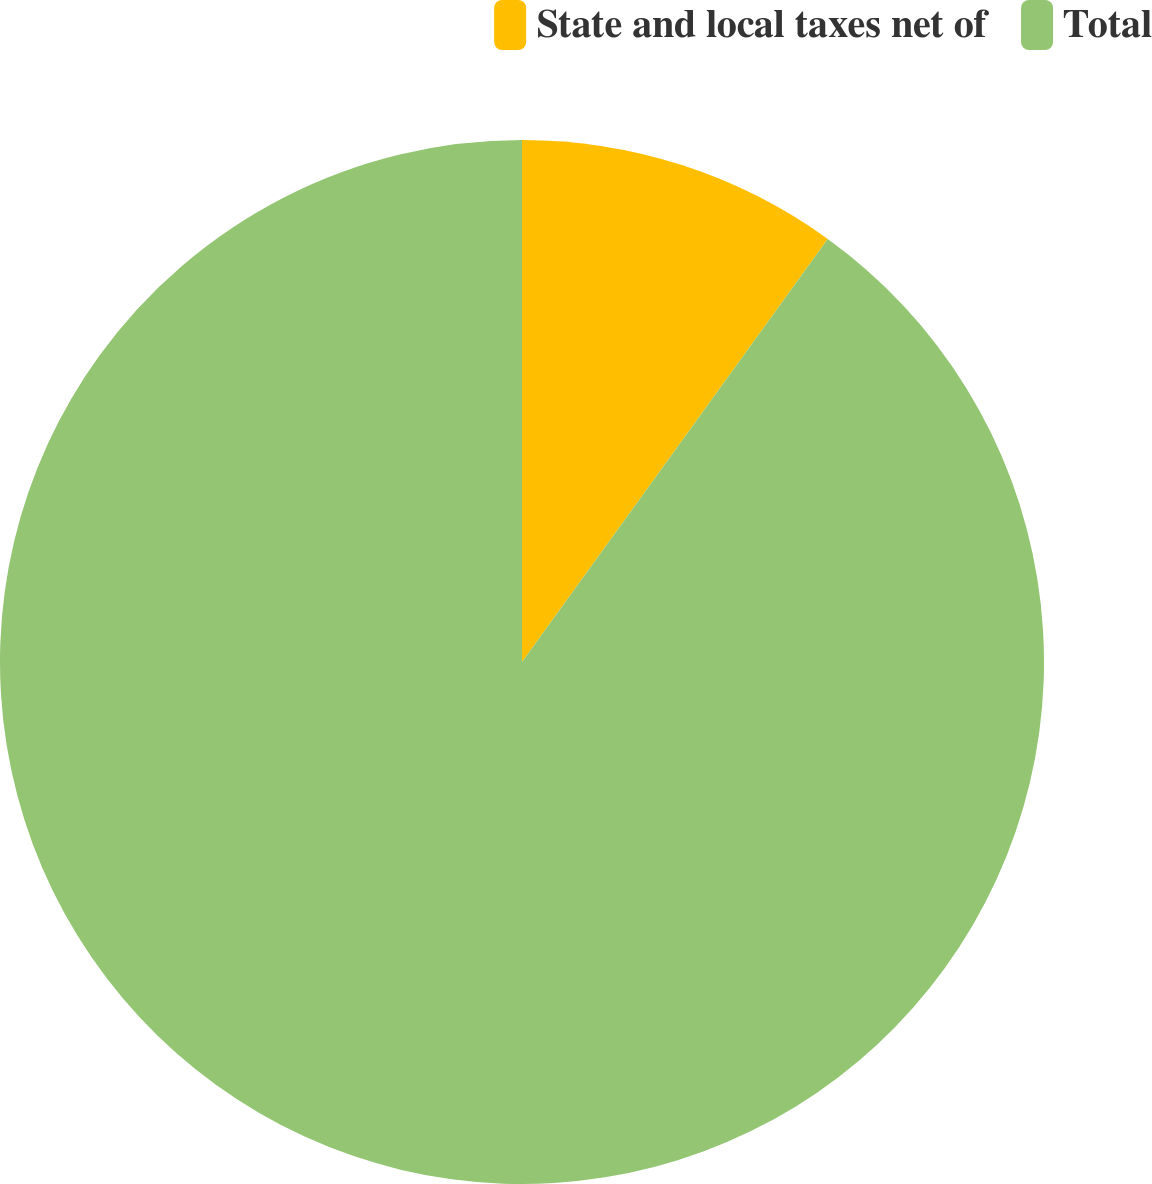<chart> <loc_0><loc_0><loc_500><loc_500><pie_chart><fcel>State and local taxes net of<fcel>Total<nl><fcel>9.96%<fcel>90.04%<nl></chart> 